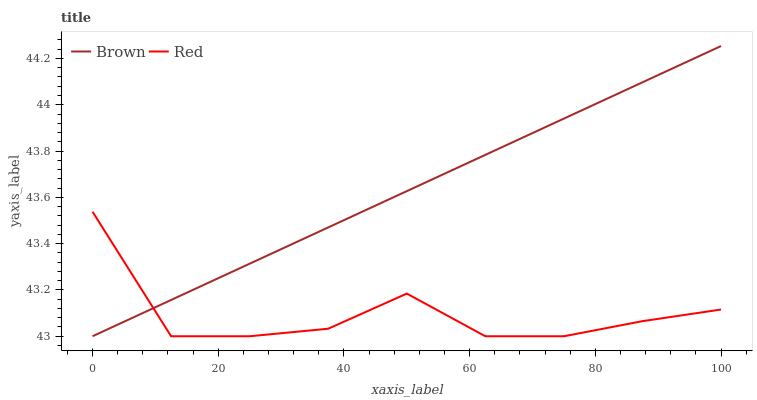Does Red have the minimum area under the curve?
Answer yes or no. Yes. Does Brown have the maximum area under the curve?
Answer yes or no. Yes. Does Red have the maximum area under the curve?
Answer yes or no. No. Is Brown the smoothest?
Answer yes or no. Yes. Is Red the roughest?
Answer yes or no. Yes. Is Red the smoothest?
Answer yes or no. No. Does Brown have the lowest value?
Answer yes or no. Yes. Does Brown have the highest value?
Answer yes or no. Yes. Does Red have the highest value?
Answer yes or no. No. Does Red intersect Brown?
Answer yes or no. Yes. Is Red less than Brown?
Answer yes or no. No. Is Red greater than Brown?
Answer yes or no. No. 